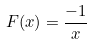<formula> <loc_0><loc_0><loc_500><loc_500>F ( x ) = \frac { - 1 } { x }</formula> 